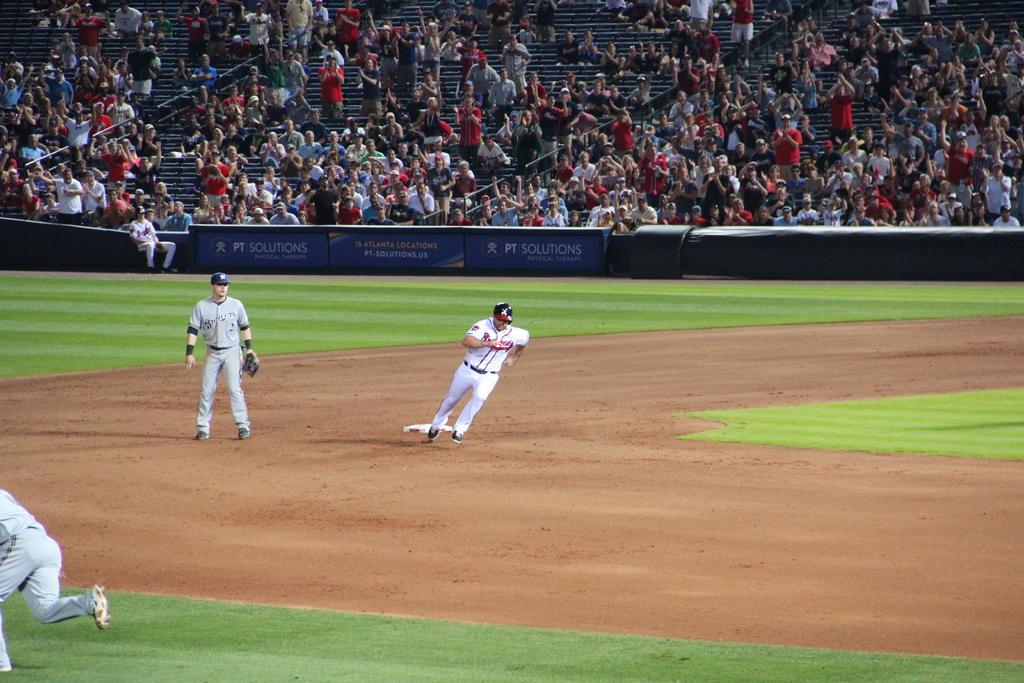Please provide a concise description of this image. In this image it seems like it is a baseball match in which there is a baseball player running on the ground. On the left side there is a player standing on the ground. In the background there are so many spectators who are watching from the stand. 